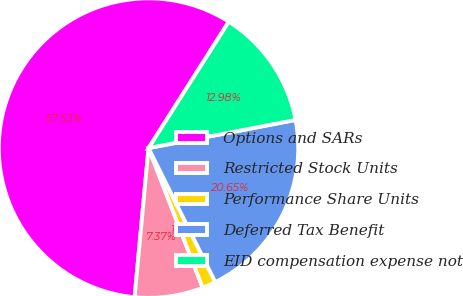Convert chart. <chart><loc_0><loc_0><loc_500><loc_500><pie_chart><fcel>Options and SARs<fcel>Restricted Stock Units<fcel>Performance Share Units<fcel>Deferred Tax Benefit<fcel>EID compensation expense not<nl><fcel>57.52%<fcel>7.37%<fcel>1.47%<fcel>20.65%<fcel>12.98%<nl></chart> 